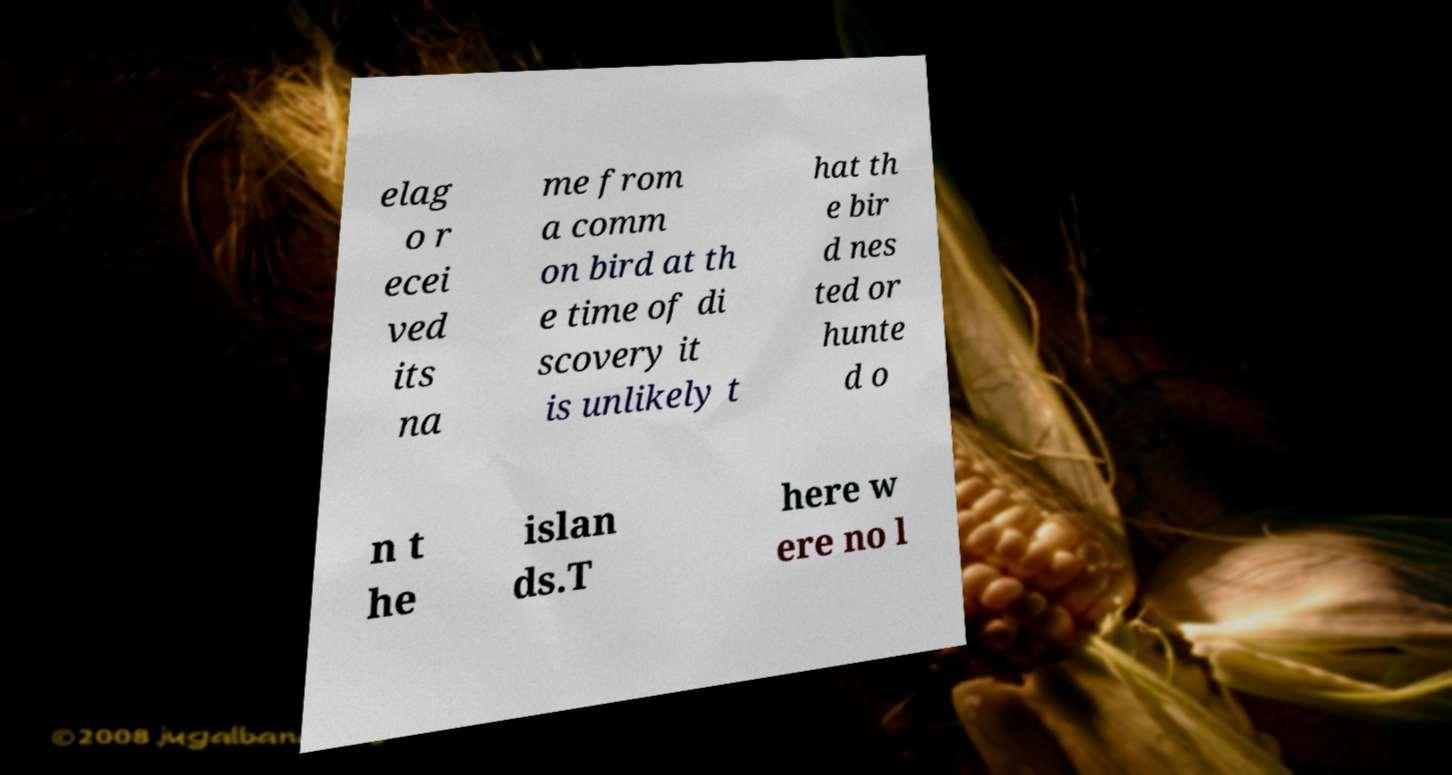Please read and relay the text visible in this image. What does it say? elag o r ecei ved its na me from a comm on bird at th e time of di scovery it is unlikely t hat th e bir d nes ted or hunte d o n t he islan ds.T here w ere no l 